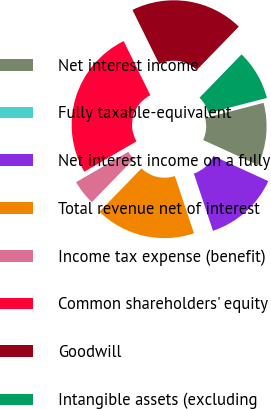Convert chart. <chart><loc_0><loc_0><loc_500><loc_500><pie_chart><fcel>Net interest income<fcel>Fully taxable-equivalent<fcel>Net interest income on a fully<fcel>Total revenue net of interest<fcel>Income tax expense (benefit)<fcel>Common shareholders' equity<fcel>Goodwill<fcel>Intangible assets (excluding<nl><fcel>10.87%<fcel>0.0%<fcel>13.04%<fcel>17.39%<fcel>4.35%<fcel>26.08%<fcel>19.56%<fcel>8.7%<nl></chart> 